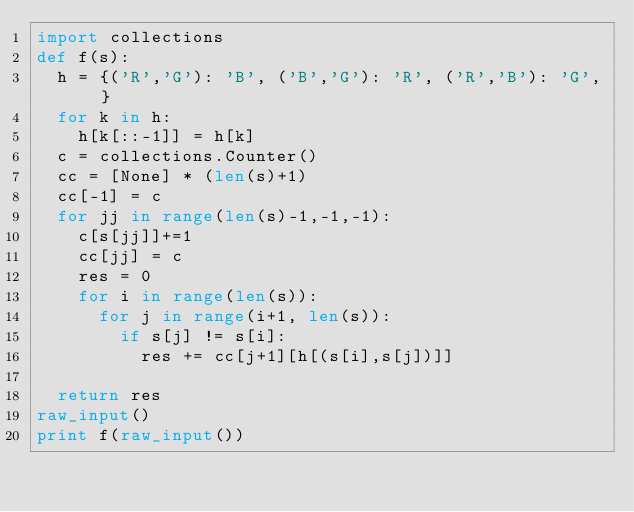Convert code to text. <code><loc_0><loc_0><loc_500><loc_500><_Python_>import collections
def f(s):
  h = {('R','G'): 'B', ('B','G'): 'R', ('R','B'): 'G', }
  for k in h:
    h[k[::-1]] = h[k]
  c = collections.Counter()
  cc = [None] * (len(s)+1)
  cc[-1] = c
  for jj in range(len(s)-1,-1,-1):
    c[s[jj]]+=1
    cc[jj] = c
    res = 0
    for i in range(len(s)):
      for j in range(i+1, len(s)):
        if s[j] != s[i]:
          res += cc[j+1][h[(s[i],s[j])]]

  return res
raw_input()
print f(raw_input())
</code> 